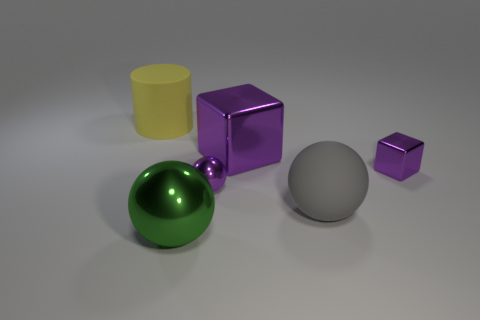Add 4 tiny spheres. How many objects exist? 10 Subtract all cubes. How many objects are left? 4 Add 4 big green metallic balls. How many big green metallic balls are left? 5 Add 6 blue matte balls. How many blue matte balls exist? 6 Subtract 1 green balls. How many objects are left? 5 Subtract all big green objects. Subtract all balls. How many objects are left? 2 